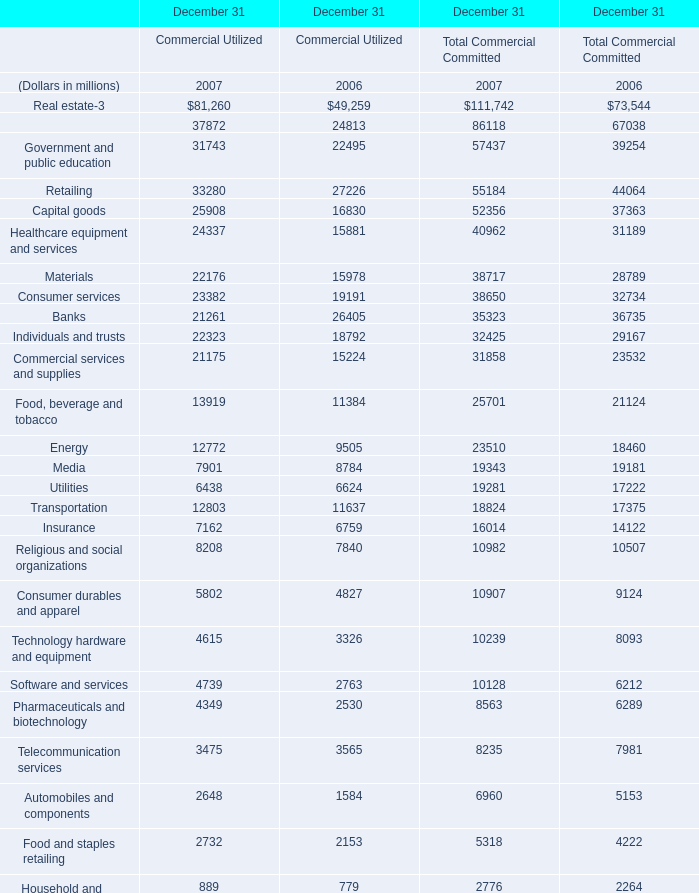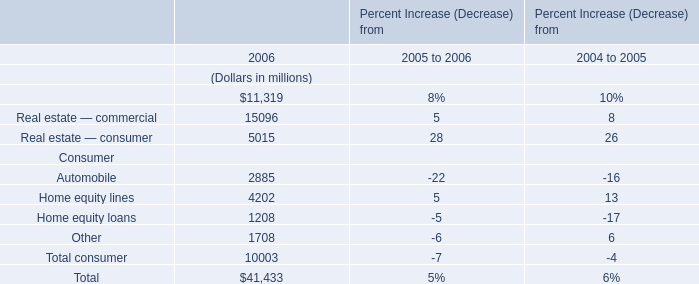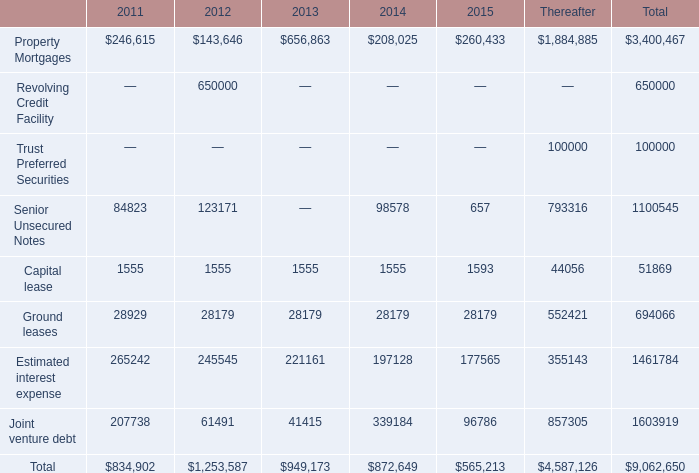What is the sum ofDiversified financials in 2007 and Commercial, financial, etc in 2006? (in millions) 
Computations: (37872 + 11319)
Answer: 49191.0. 